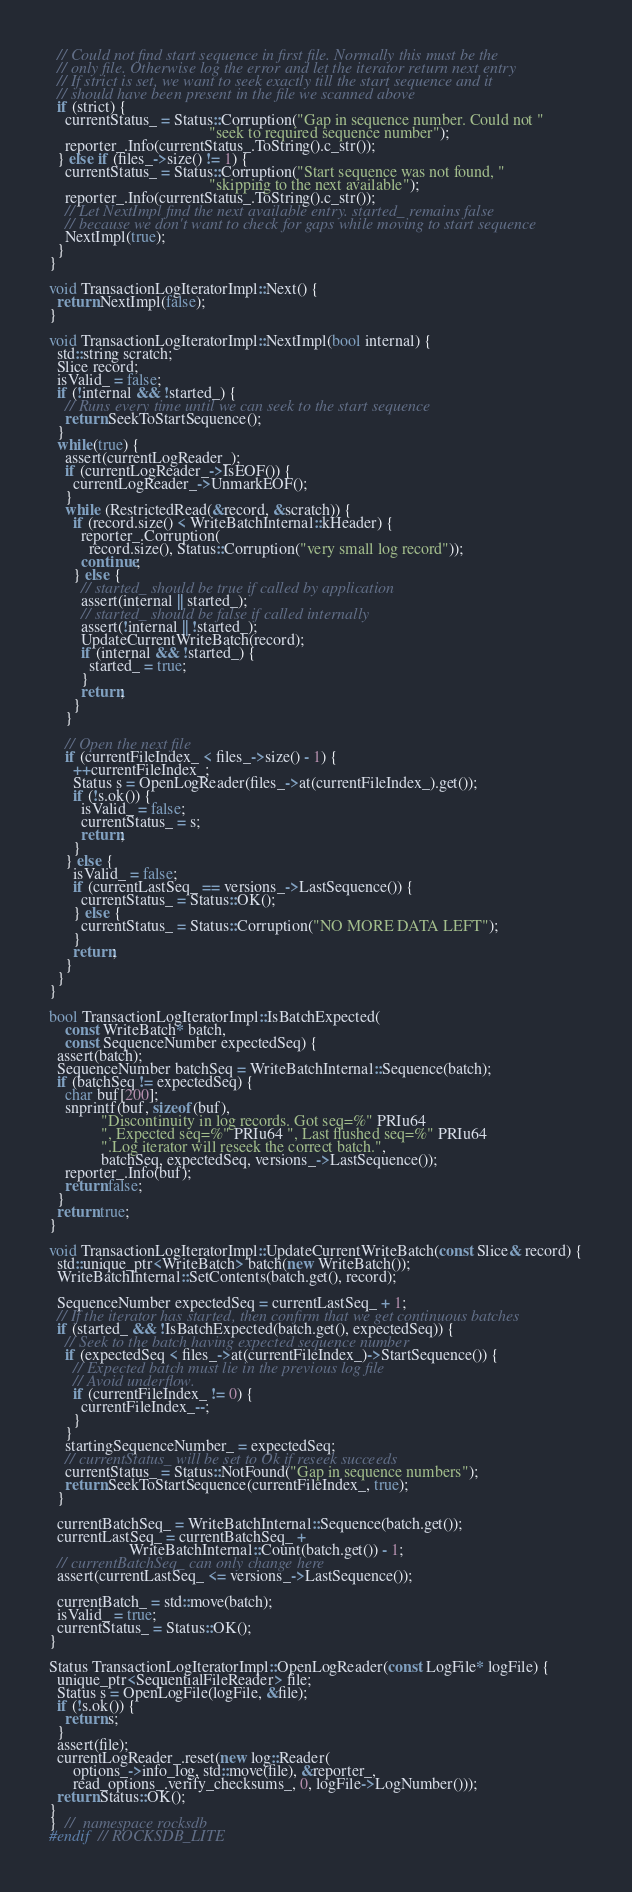Convert code to text. <code><loc_0><loc_0><loc_500><loc_500><_C++_>  // Could not find start sequence in first file. Normally this must be the
  // only file. Otherwise log the error and let the iterator return next entry
  // If strict is set, we want to seek exactly till the start sequence and it
  // should have been present in the file we scanned above
  if (strict) {
    currentStatus_ = Status::Corruption("Gap in sequence number. Could not "
                                        "seek to required sequence number");
    reporter_.Info(currentStatus_.ToString().c_str());
  } else if (files_->size() != 1) {
    currentStatus_ = Status::Corruption("Start sequence was not found, "
                                        "skipping to the next available");
    reporter_.Info(currentStatus_.ToString().c_str());
    // Let NextImpl find the next available entry. started_ remains false
    // because we don't want to check for gaps while moving to start sequence
    NextImpl(true);
  }
}

void TransactionLogIteratorImpl::Next() {
  return NextImpl(false);
}

void TransactionLogIteratorImpl::NextImpl(bool internal) {
  std::string scratch;
  Slice record;
  isValid_ = false;
  if (!internal && !started_) {
    // Runs every time until we can seek to the start sequence
    return SeekToStartSequence();
  }
  while(true) {
    assert(currentLogReader_);
    if (currentLogReader_->IsEOF()) {
      currentLogReader_->UnmarkEOF();
    }
    while (RestrictedRead(&record, &scratch)) {
      if (record.size() < WriteBatchInternal::kHeader) {
        reporter_.Corruption(
          record.size(), Status::Corruption("very small log record"));
        continue;
      } else {
        // started_ should be true if called by application
        assert(internal || started_);
        // started_ should be false if called internally
        assert(!internal || !started_);
        UpdateCurrentWriteBatch(record);
        if (internal && !started_) {
          started_ = true;
        }
        return;
      }
    }

    // Open the next file
    if (currentFileIndex_ < files_->size() - 1) {
      ++currentFileIndex_;
      Status s = OpenLogReader(files_->at(currentFileIndex_).get());
      if (!s.ok()) {
        isValid_ = false;
        currentStatus_ = s;
        return;
      }
    } else {
      isValid_ = false;
      if (currentLastSeq_ == versions_->LastSequence()) {
        currentStatus_ = Status::OK();
      } else {
        currentStatus_ = Status::Corruption("NO MORE DATA LEFT");
      }
      return;
    }
  }
}

bool TransactionLogIteratorImpl::IsBatchExpected(
    const WriteBatch* batch,
    const SequenceNumber expectedSeq) {
  assert(batch);
  SequenceNumber batchSeq = WriteBatchInternal::Sequence(batch);
  if (batchSeq != expectedSeq) {
    char buf[200];
    snprintf(buf, sizeof(buf),
             "Discontinuity in log records. Got seq=%" PRIu64
             ", Expected seq=%" PRIu64 ", Last flushed seq=%" PRIu64
             ".Log iterator will reseek the correct batch.",
             batchSeq, expectedSeq, versions_->LastSequence());
    reporter_.Info(buf);
    return false;
  }
  return true;
}

void TransactionLogIteratorImpl::UpdateCurrentWriteBatch(const Slice& record) {
  std::unique_ptr<WriteBatch> batch(new WriteBatch());
  WriteBatchInternal::SetContents(batch.get(), record);

  SequenceNumber expectedSeq = currentLastSeq_ + 1;
  // If the iterator has started, then confirm that we get continuous batches
  if (started_ && !IsBatchExpected(batch.get(), expectedSeq)) {
    // Seek to the batch having expected sequence number
    if (expectedSeq < files_->at(currentFileIndex_)->StartSequence()) {
      // Expected batch must lie in the previous log file
      // Avoid underflow.
      if (currentFileIndex_ != 0) {
        currentFileIndex_--;
      }
    }
    startingSequenceNumber_ = expectedSeq;
    // currentStatus_ will be set to Ok if reseek succeeds
    currentStatus_ = Status::NotFound("Gap in sequence numbers");
    return SeekToStartSequence(currentFileIndex_, true);
  }

  currentBatchSeq_ = WriteBatchInternal::Sequence(batch.get());
  currentLastSeq_ = currentBatchSeq_ +
                    WriteBatchInternal::Count(batch.get()) - 1;
  // currentBatchSeq_ can only change here
  assert(currentLastSeq_ <= versions_->LastSequence());

  currentBatch_ = std::move(batch);
  isValid_ = true;
  currentStatus_ = Status::OK();
}

Status TransactionLogIteratorImpl::OpenLogReader(const LogFile* logFile) {
  unique_ptr<SequentialFileReader> file;
  Status s = OpenLogFile(logFile, &file);
  if (!s.ok()) {
    return s;
  }
  assert(file);
  currentLogReader_.reset(new log::Reader(
      options_->info_log, std::move(file), &reporter_,
      read_options_.verify_checksums_, 0, logFile->LogNumber()));
  return Status::OK();
}
}  //  namespace rocksdb
#endif  // ROCKSDB_LITE
</code> 